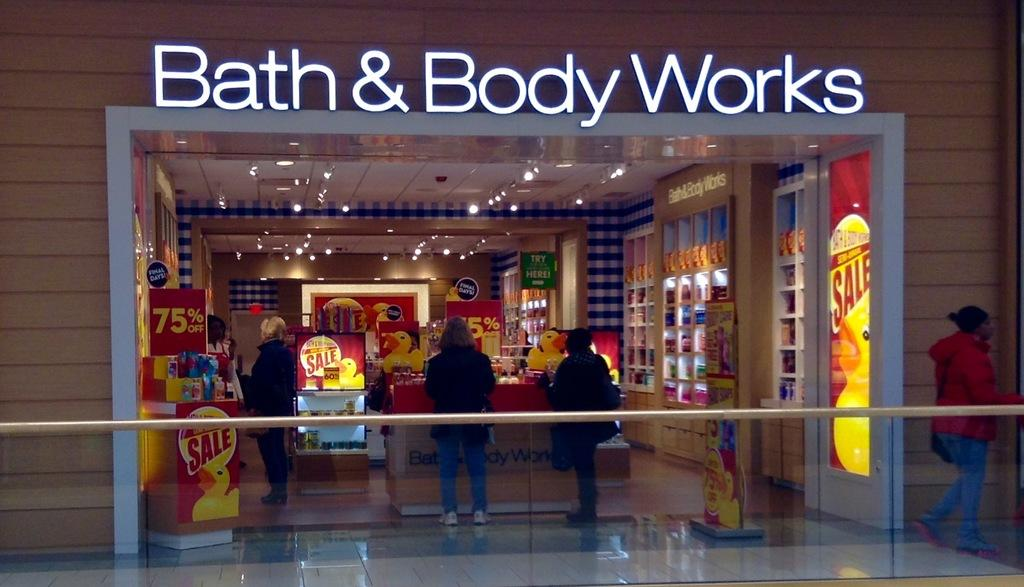What type of establishment is visible in the image? There is a shop in the image. Are there any people present near the shop? Yes, three people are standing in front of the shop. Can you describe the lady walking on the right side of the image? The lady is wearing a red jacket and jeans. What is the lady doing in the image? The lady is walking on the right side of the image. What type of mine can be seen in the background of the image? There is no mine present in the image. Are there any hills visible in the image? There is no hill present in the image. Can you spot any cactus plants in the image? There is no cactus plant present in the image. 